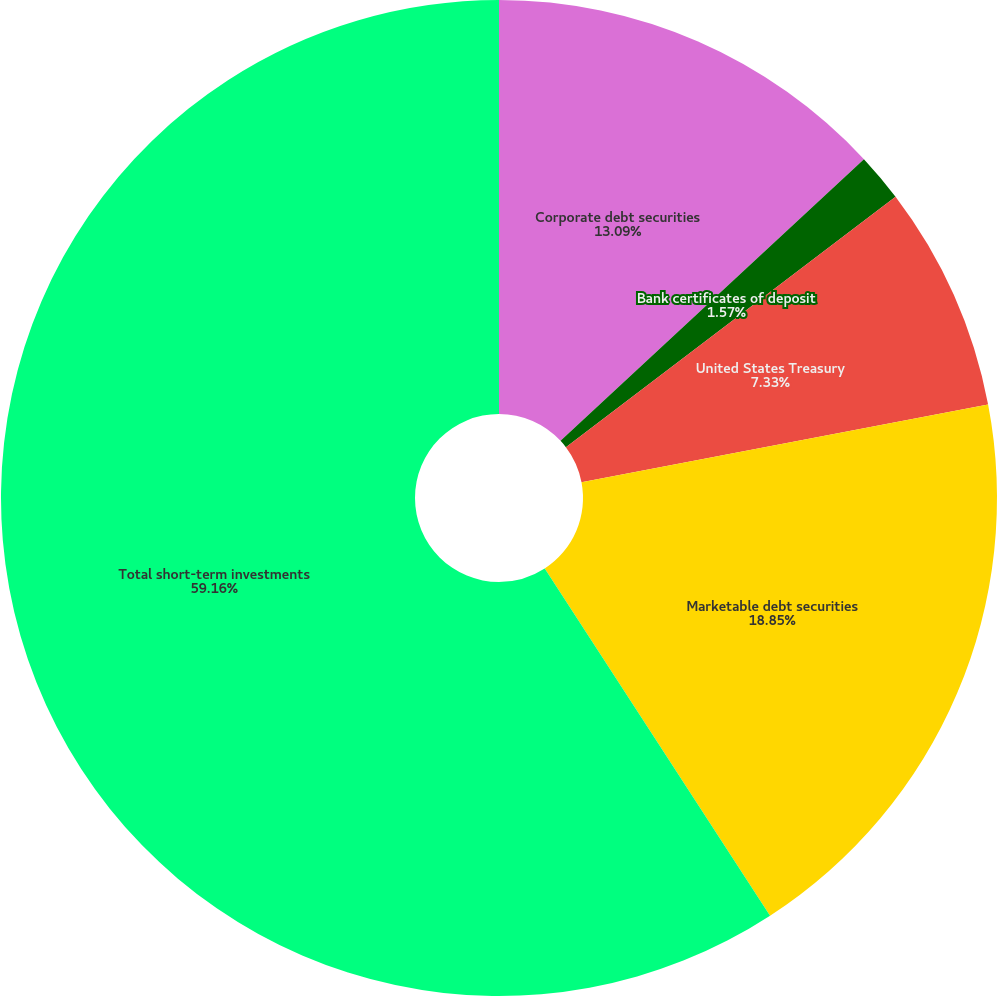Convert chart to OTSL. <chart><loc_0><loc_0><loc_500><loc_500><pie_chart><fcel>Corporate debt securities<fcel>Bank certificates of deposit<fcel>United States Treasury<fcel>Marketable debt securities<fcel>Total short-term investments<nl><fcel>13.09%<fcel>1.57%<fcel>7.33%<fcel>18.85%<fcel>59.16%<nl></chart> 